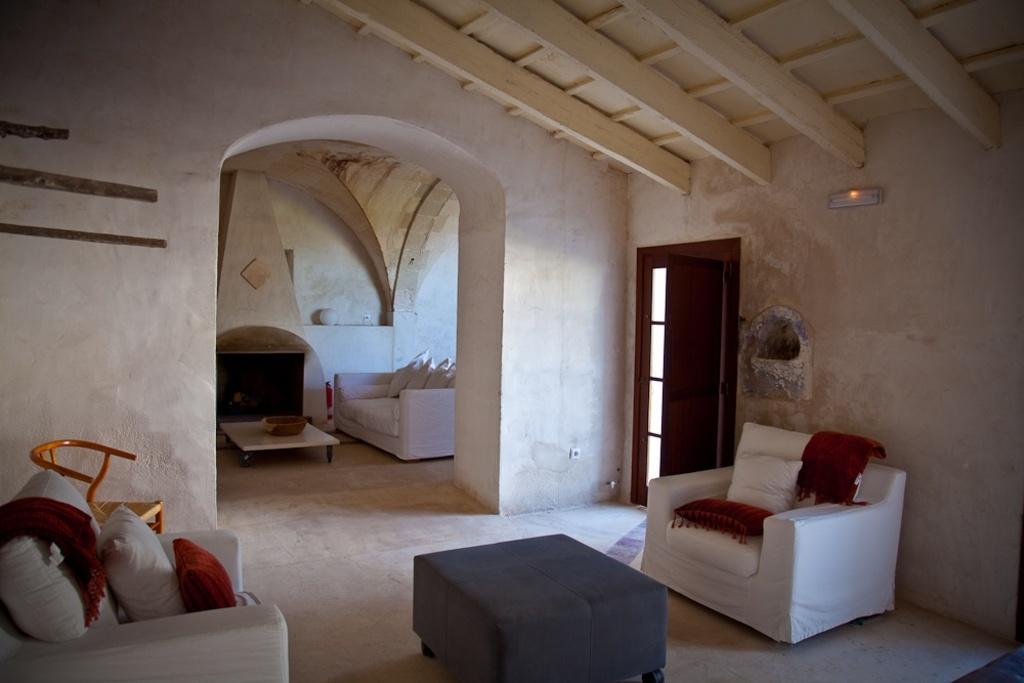Could you give a brief overview of what you see in this image? There are sofas and these are the pillows. This is table. There is a bowl and this is floor. Here we can see a chair. In the background there is a wall and this is door. There is a light and this is roof. 